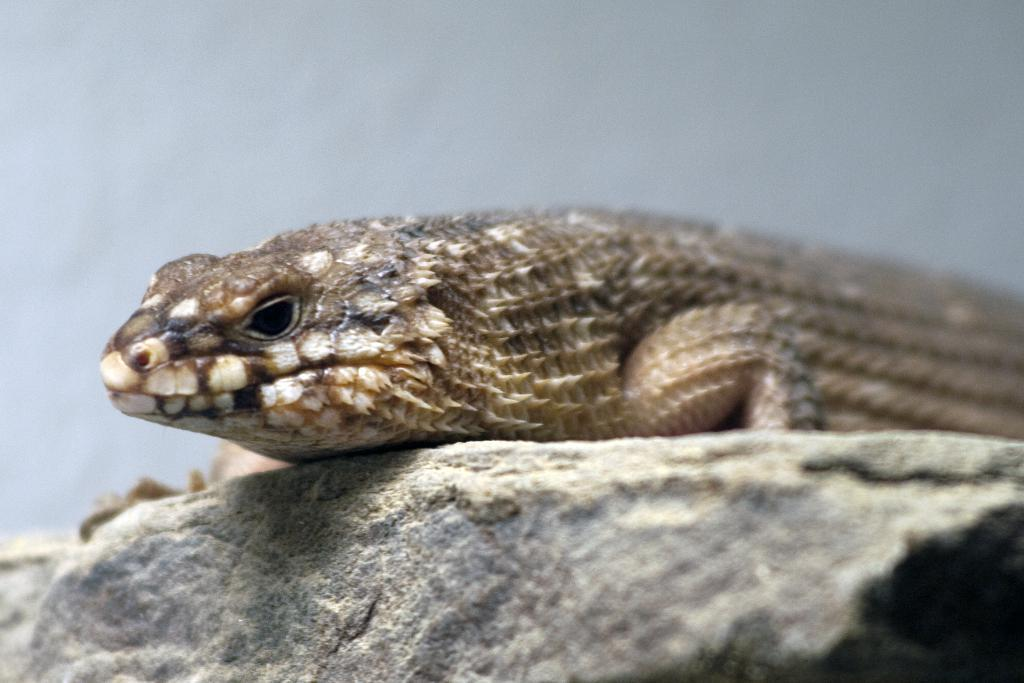What type of animal is in the picture? There is a reptile in the picture. What object can be seen at the bottom of the picture? There is a rock at the bottom of the picture. What might be the background of the image? The background of the image appears to be white and might be a wall. What type of market can be seen in the image? There is no market present in the image. 